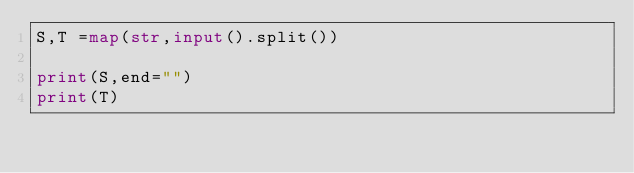<code> <loc_0><loc_0><loc_500><loc_500><_Python_>S,T =map(str,input().split())

print(S,end="")
print(T)</code> 